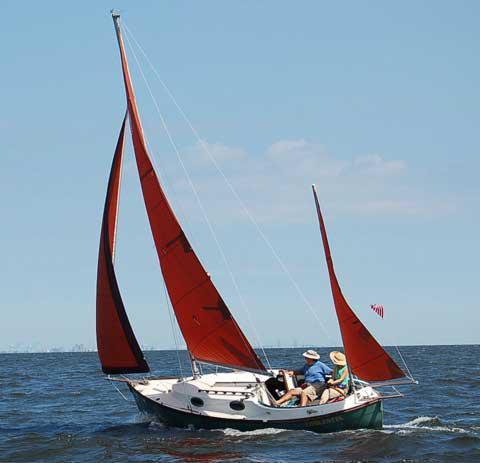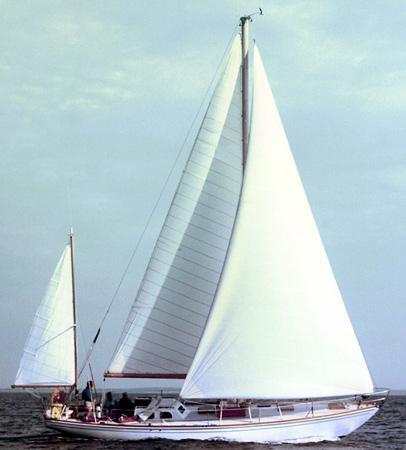The first image is the image on the left, the second image is the image on the right. Analyze the images presented: Is the assertion "There are exactly three inflated sails in the image on the right." valid? Answer yes or no. Yes. 